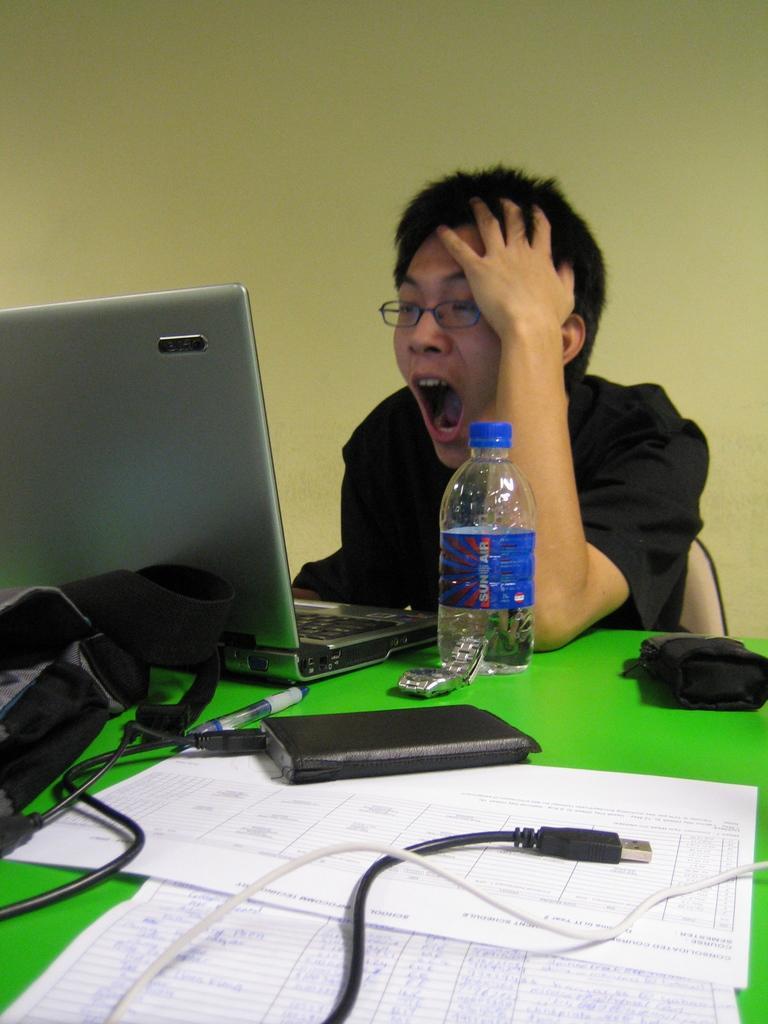Could you give a brief overview of what you see in this image? This picture describes about a person seated on the chair and working with laptop, in front of the person we can see bottle, watch some objects. 